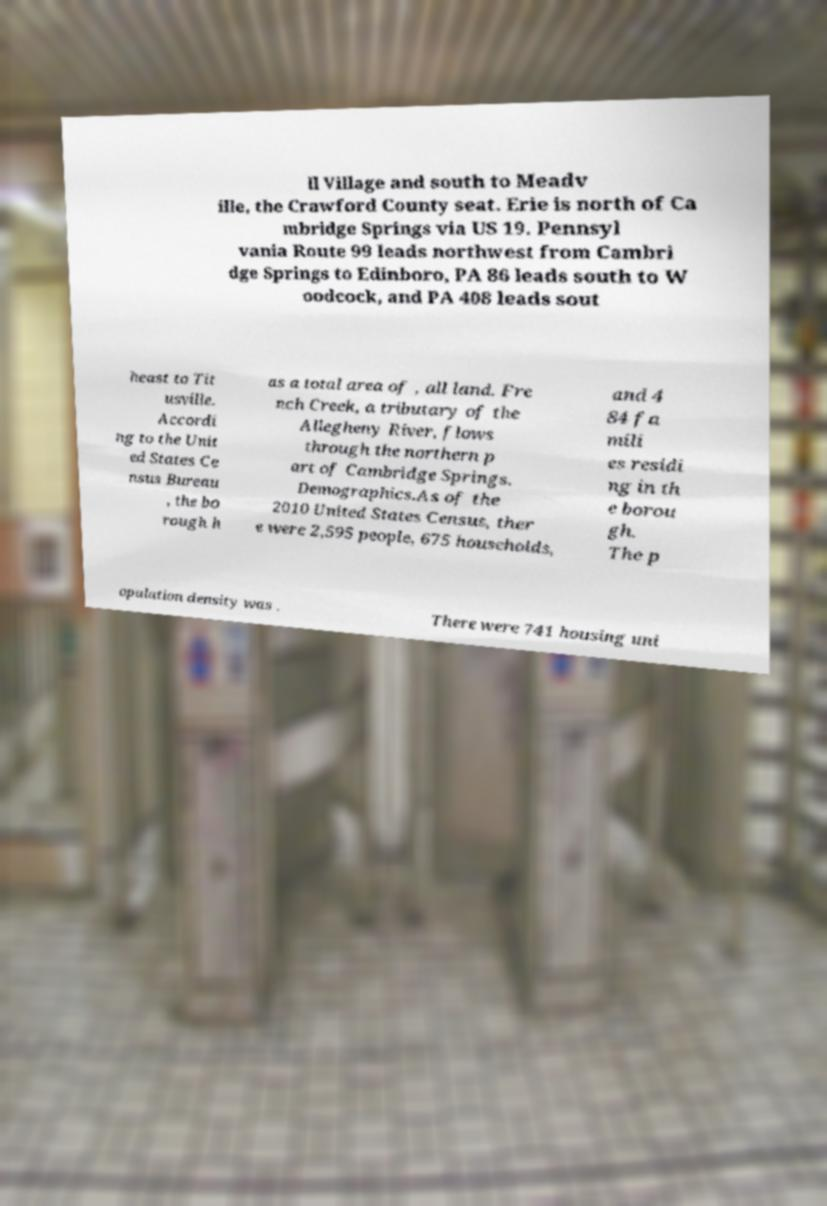There's text embedded in this image that I need extracted. Can you transcribe it verbatim? ll Village and south to Meadv ille, the Crawford County seat. Erie is north of Ca mbridge Springs via US 19. Pennsyl vania Route 99 leads northwest from Cambri dge Springs to Edinboro, PA 86 leads south to W oodcock, and PA 408 leads sout heast to Tit usville. Accordi ng to the Unit ed States Ce nsus Bureau , the bo rough h as a total area of , all land. Fre nch Creek, a tributary of the Allegheny River, flows through the northern p art of Cambridge Springs. Demographics.As of the 2010 United States Census, ther e were 2,595 people, 675 households, and 4 84 fa mili es residi ng in th e borou gh. The p opulation density was . There were 741 housing uni 